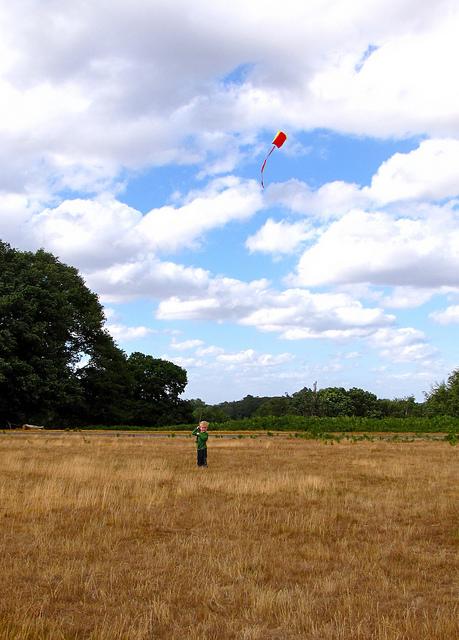Is it overcast or sunny?
Be succinct. Sunny. What tall object in the photo matches the color of the boy's shirt?
Quick response, please. Tree. What is the color of the kite?
Give a very brief answer. Red. Is the sky clear?
Be succinct. No. 